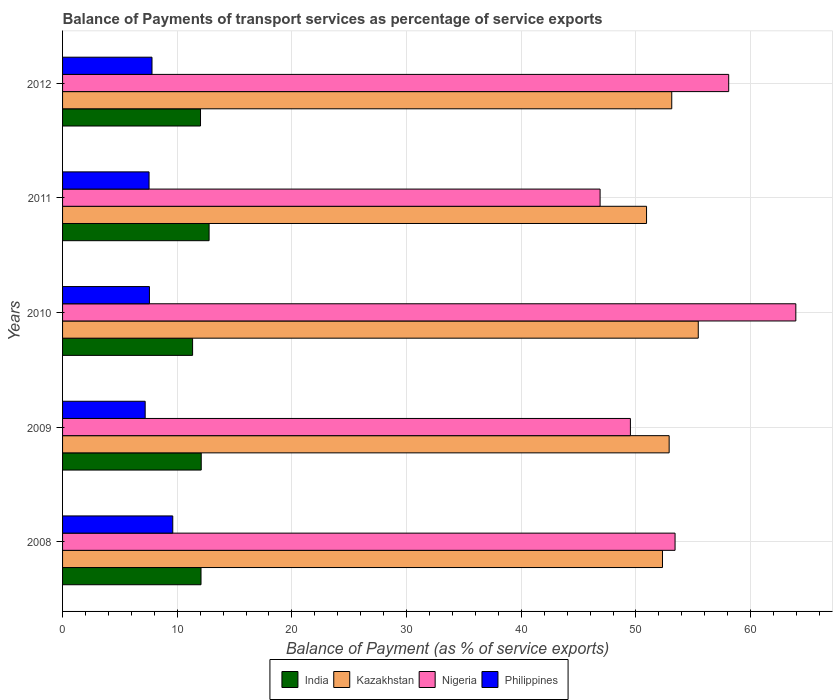How many different coloured bars are there?
Your answer should be very brief. 4. How many groups of bars are there?
Keep it short and to the point. 5. Are the number of bars per tick equal to the number of legend labels?
Give a very brief answer. Yes. Are the number of bars on each tick of the Y-axis equal?
Your answer should be very brief. Yes. How many bars are there on the 1st tick from the top?
Make the answer very short. 4. How many bars are there on the 1st tick from the bottom?
Provide a succinct answer. 4. What is the balance of payments of transport services in Philippines in 2011?
Provide a succinct answer. 7.54. Across all years, what is the maximum balance of payments of transport services in Philippines?
Give a very brief answer. 9.61. Across all years, what is the minimum balance of payments of transport services in Kazakhstan?
Offer a very short reply. 50.93. In which year was the balance of payments of transport services in Nigeria maximum?
Provide a succinct answer. 2010. In which year was the balance of payments of transport services in Nigeria minimum?
Give a very brief answer. 2011. What is the total balance of payments of transport services in Nigeria in the graph?
Offer a very short reply. 271.84. What is the difference between the balance of payments of transport services in Kazakhstan in 2009 and that in 2010?
Make the answer very short. -2.54. What is the difference between the balance of payments of transport services in Nigeria in 2009 and the balance of payments of transport services in Kazakhstan in 2011?
Your answer should be compact. -1.41. What is the average balance of payments of transport services in Philippines per year?
Offer a very short reply. 7.95. In the year 2009, what is the difference between the balance of payments of transport services in Nigeria and balance of payments of transport services in India?
Your answer should be compact. 37.43. What is the ratio of the balance of payments of transport services in Philippines in 2010 to that in 2011?
Ensure brevity in your answer.  1. Is the difference between the balance of payments of transport services in Nigeria in 2009 and 2010 greater than the difference between the balance of payments of transport services in India in 2009 and 2010?
Provide a succinct answer. No. What is the difference between the highest and the second highest balance of payments of transport services in India?
Offer a very short reply. 0.69. What is the difference between the highest and the lowest balance of payments of transport services in Nigeria?
Offer a terse response. 17.07. In how many years, is the balance of payments of transport services in Nigeria greater than the average balance of payments of transport services in Nigeria taken over all years?
Offer a terse response. 2. Is it the case that in every year, the sum of the balance of payments of transport services in Philippines and balance of payments of transport services in India is greater than the sum of balance of payments of transport services in Nigeria and balance of payments of transport services in Kazakhstan?
Offer a very short reply. No. What does the 4th bar from the top in 2011 represents?
Your answer should be compact. India. What does the 4th bar from the bottom in 2010 represents?
Provide a succinct answer. Philippines. How many years are there in the graph?
Your answer should be compact. 5. How are the legend labels stacked?
Your response must be concise. Horizontal. What is the title of the graph?
Your answer should be very brief. Balance of Payments of transport services as percentage of service exports. Does "Cameroon" appear as one of the legend labels in the graph?
Your answer should be very brief. No. What is the label or title of the X-axis?
Ensure brevity in your answer.  Balance of Payment (as % of service exports). What is the Balance of Payment (as % of service exports) in India in 2008?
Your answer should be compact. 12.07. What is the Balance of Payment (as % of service exports) in Kazakhstan in 2008?
Your answer should be very brief. 52.32. What is the Balance of Payment (as % of service exports) in Nigeria in 2008?
Make the answer very short. 53.41. What is the Balance of Payment (as % of service exports) in Philippines in 2008?
Your response must be concise. 9.61. What is the Balance of Payment (as % of service exports) in India in 2009?
Offer a very short reply. 12.09. What is the Balance of Payment (as % of service exports) of Kazakhstan in 2009?
Ensure brevity in your answer.  52.9. What is the Balance of Payment (as % of service exports) of Nigeria in 2009?
Give a very brief answer. 49.52. What is the Balance of Payment (as % of service exports) in Philippines in 2009?
Your answer should be compact. 7.2. What is the Balance of Payment (as % of service exports) of India in 2010?
Provide a succinct answer. 11.34. What is the Balance of Payment (as % of service exports) of Kazakhstan in 2010?
Give a very brief answer. 55.44. What is the Balance of Payment (as % of service exports) in Nigeria in 2010?
Give a very brief answer. 63.94. What is the Balance of Payment (as % of service exports) of Philippines in 2010?
Make the answer very short. 7.58. What is the Balance of Payment (as % of service exports) in India in 2011?
Your answer should be very brief. 12.78. What is the Balance of Payment (as % of service exports) of Kazakhstan in 2011?
Offer a terse response. 50.93. What is the Balance of Payment (as % of service exports) of Nigeria in 2011?
Your answer should be very brief. 46.87. What is the Balance of Payment (as % of service exports) in Philippines in 2011?
Offer a terse response. 7.54. What is the Balance of Payment (as % of service exports) in India in 2012?
Ensure brevity in your answer.  12.03. What is the Balance of Payment (as % of service exports) of Kazakhstan in 2012?
Your response must be concise. 53.12. What is the Balance of Payment (as % of service exports) in Nigeria in 2012?
Your answer should be very brief. 58.09. What is the Balance of Payment (as % of service exports) of Philippines in 2012?
Your answer should be very brief. 7.8. Across all years, what is the maximum Balance of Payment (as % of service exports) of India?
Your answer should be compact. 12.78. Across all years, what is the maximum Balance of Payment (as % of service exports) in Kazakhstan?
Provide a succinct answer. 55.44. Across all years, what is the maximum Balance of Payment (as % of service exports) of Nigeria?
Give a very brief answer. 63.94. Across all years, what is the maximum Balance of Payment (as % of service exports) of Philippines?
Make the answer very short. 9.61. Across all years, what is the minimum Balance of Payment (as % of service exports) in India?
Provide a succinct answer. 11.34. Across all years, what is the minimum Balance of Payment (as % of service exports) in Kazakhstan?
Your answer should be very brief. 50.93. Across all years, what is the minimum Balance of Payment (as % of service exports) of Nigeria?
Keep it short and to the point. 46.87. Across all years, what is the minimum Balance of Payment (as % of service exports) of Philippines?
Your response must be concise. 7.2. What is the total Balance of Payment (as % of service exports) in India in the graph?
Keep it short and to the point. 60.31. What is the total Balance of Payment (as % of service exports) in Kazakhstan in the graph?
Ensure brevity in your answer.  264.7. What is the total Balance of Payment (as % of service exports) of Nigeria in the graph?
Provide a short and direct response. 271.84. What is the total Balance of Payment (as % of service exports) of Philippines in the graph?
Your answer should be compact. 39.73. What is the difference between the Balance of Payment (as % of service exports) of India in 2008 and that in 2009?
Your answer should be very brief. -0.02. What is the difference between the Balance of Payment (as % of service exports) of Kazakhstan in 2008 and that in 2009?
Provide a short and direct response. -0.58. What is the difference between the Balance of Payment (as % of service exports) of Nigeria in 2008 and that in 2009?
Make the answer very short. 3.89. What is the difference between the Balance of Payment (as % of service exports) in Philippines in 2008 and that in 2009?
Ensure brevity in your answer.  2.41. What is the difference between the Balance of Payment (as % of service exports) of India in 2008 and that in 2010?
Make the answer very short. 0.73. What is the difference between the Balance of Payment (as % of service exports) of Kazakhstan in 2008 and that in 2010?
Make the answer very short. -3.12. What is the difference between the Balance of Payment (as % of service exports) in Nigeria in 2008 and that in 2010?
Provide a succinct answer. -10.53. What is the difference between the Balance of Payment (as % of service exports) of Philippines in 2008 and that in 2010?
Provide a short and direct response. 2.03. What is the difference between the Balance of Payment (as % of service exports) in India in 2008 and that in 2011?
Make the answer very short. -0.7. What is the difference between the Balance of Payment (as % of service exports) of Kazakhstan in 2008 and that in 2011?
Your answer should be compact. 1.39. What is the difference between the Balance of Payment (as % of service exports) in Nigeria in 2008 and that in 2011?
Offer a terse response. 6.54. What is the difference between the Balance of Payment (as % of service exports) in Philippines in 2008 and that in 2011?
Keep it short and to the point. 2.07. What is the difference between the Balance of Payment (as % of service exports) of India in 2008 and that in 2012?
Provide a succinct answer. 0.04. What is the difference between the Balance of Payment (as % of service exports) of Kazakhstan in 2008 and that in 2012?
Keep it short and to the point. -0.81. What is the difference between the Balance of Payment (as % of service exports) of Nigeria in 2008 and that in 2012?
Give a very brief answer. -4.68. What is the difference between the Balance of Payment (as % of service exports) in Philippines in 2008 and that in 2012?
Your answer should be compact. 1.81. What is the difference between the Balance of Payment (as % of service exports) of India in 2009 and that in 2010?
Provide a succinct answer. 0.75. What is the difference between the Balance of Payment (as % of service exports) of Kazakhstan in 2009 and that in 2010?
Provide a short and direct response. -2.54. What is the difference between the Balance of Payment (as % of service exports) of Nigeria in 2009 and that in 2010?
Offer a terse response. -14.43. What is the difference between the Balance of Payment (as % of service exports) of Philippines in 2009 and that in 2010?
Your answer should be very brief. -0.37. What is the difference between the Balance of Payment (as % of service exports) of India in 2009 and that in 2011?
Your answer should be very brief. -0.69. What is the difference between the Balance of Payment (as % of service exports) of Kazakhstan in 2009 and that in 2011?
Your response must be concise. 1.97. What is the difference between the Balance of Payment (as % of service exports) in Nigeria in 2009 and that in 2011?
Offer a very short reply. 2.64. What is the difference between the Balance of Payment (as % of service exports) of Philippines in 2009 and that in 2011?
Ensure brevity in your answer.  -0.34. What is the difference between the Balance of Payment (as % of service exports) in India in 2009 and that in 2012?
Provide a succinct answer. 0.06. What is the difference between the Balance of Payment (as % of service exports) of Kazakhstan in 2009 and that in 2012?
Give a very brief answer. -0.23. What is the difference between the Balance of Payment (as % of service exports) of Nigeria in 2009 and that in 2012?
Keep it short and to the point. -8.57. What is the difference between the Balance of Payment (as % of service exports) of Philippines in 2009 and that in 2012?
Give a very brief answer. -0.59. What is the difference between the Balance of Payment (as % of service exports) of India in 2010 and that in 2011?
Your answer should be very brief. -1.44. What is the difference between the Balance of Payment (as % of service exports) in Kazakhstan in 2010 and that in 2011?
Keep it short and to the point. 4.51. What is the difference between the Balance of Payment (as % of service exports) in Nigeria in 2010 and that in 2011?
Provide a succinct answer. 17.07. What is the difference between the Balance of Payment (as % of service exports) in Philippines in 2010 and that in 2011?
Your answer should be compact. 0.03. What is the difference between the Balance of Payment (as % of service exports) in India in 2010 and that in 2012?
Make the answer very short. -0.69. What is the difference between the Balance of Payment (as % of service exports) in Kazakhstan in 2010 and that in 2012?
Give a very brief answer. 2.31. What is the difference between the Balance of Payment (as % of service exports) in Nigeria in 2010 and that in 2012?
Your answer should be very brief. 5.85. What is the difference between the Balance of Payment (as % of service exports) in Philippines in 2010 and that in 2012?
Offer a very short reply. -0.22. What is the difference between the Balance of Payment (as % of service exports) in India in 2011 and that in 2012?
Your answer should be compact. 0.75. What is the difference between the Balance of Payment (as % of service exports) in Kazakhstan in 2011 and that in 2012?
Offer a very short reply. -2.2. What is the difference between the Balance of Payment (as % of service exports) in Nigeria in 2011 and that in 2012?
Make the answer very short. -11.22. What is the difference between the Balance of Payment (as % of service exports) of Philippines in 2011 and that in 2012?
Provide a succinct answer. -0.26. What is the difference between the Balance of Payment (as % of service exports) in India in 2008 and the Balance of Payment (as % of service exports) in Kazakhstan in 2009?
Provide a succinct answer. -40.82. What is the difference between the Balance of Payment (as % of service exports) in India in 2008 and the Balance of Payment (as % of service exports) in Nigeria in 2009?
Your response must be concise. -37.45. What is the difference between the Balance of Payment (as % of service exports) in India in 2008 and the Balance of Payment (as % of service exports) in Philippines in 2009?
Offer a very short reply. 4.87. What is the difference between the Balance of Payment (as % of service exports) in Kazakhstan in 2008 and the Balance of Payment (as % of service exports) in Nigeria in 2009?
Your response must be concise. 2.8. What is the difference between the Balance of Payment (as % of service exports) of Kazakhstan in 2008 and the Balance of Payment (as % of service exports) of Philippines in 2009?
Provide a short and direct response. 45.11. What is the difference between the Balance of Payment (as % of service exports) in Nigeria in 2008 and the Balance of Payment (as % of service exports) in Philippines in 2009?
Provide a succinct answer. 46.21. What is the difference between the Balance of Payment (as % of service exports) of India in 2008 and the Balance of Payment (as % of service exports) of Kazakhstan in 2010?
Your answer should be compact. -43.36. What is the difference between the Balance of Payment (as % of service exports) in India in 2008 and the Balance of Payment (as % of service exports) in Nigeria in 2010?
Provide a succinct answer. -51.87. What is the difference between the Balance of Payment (as % of service exports) of India in 2008 and the Balance of Payment (as % of service exports) of Philippines in 2010?
Provide a succinct answer. 4.5. What is the difference between the Balance of Payment (as % of service exports) of Kazakhstan in 2008 and the Balance of Payment (as % of service exports) of Nigeria in 2010?
Provide a short and direct response. -11.63. What is the difference between the Balance of Payment (as % of service exports) of Kazakhstan in 2008 and the Balance of Payment (as % of service exports) of Philippines in 2010?
Your response must be concise. 44.74. What is the difference between the Balance of Payment (as % of service exports) of Nigeria in 2008 and the Balance of Payment (as % of service exports) of Philippines in 2010?
Offer a terse response. 45.84. What is the difference between the Balance of Payment (as % of service exports) in India in 2008 and the Balance of Payment (as % of service exports) in Kazakhstan in 2011?
Your answer should be very brief. -38.85. What is the difference between the Balance of Payment (as % of service exports) in India in 2008 and the Balance of Payment (as % of service exports) in Nigeria in 2011?
Your answer should be compact. -34.8. What is the difference between the Balance of Payment (as % of service exports) of India in 2008 and the Balance of Payment (as % of service exports) of Philippines in 2011?
Give a very brief answer. 4.53. What is the difference between the Balance of Payment (as % of service exports) of Kazakhstan in 2008 and the Balance of Payment (as % of service exports) of Nigeria in 2011?
Keep it short and to the point. 5.44. What is the difference between the Balance of Payment (as % of service exports) of Kazakhstan in 2008 and the Balance of Payment (as % of service exports) of Philippines in 2011?
Your answer should be compact. 44.77. What is the difference between the Balance of Payment (as % of service exports) in Nigeria in 2008 and the Balance of Payment (as % of service exports) in Philippines in 2011?
Your answer should be compact. 45.87. What is the difference between the Balance of Payment (as % of service exports) of India in 2008 and the Balance of Payment (as % of service exports) of Kazakhstan in 2012?
Ensure brevity in your answer.  -41.05. What is the difference between the Balance of Payment (as % of service exports) in India in 2008 and the Balance of Payment (as % of service exports) in Nigeria in 2012?
Your answer should be compact. -46.02. What is the difference between the Balance of Payment (as % of service exports) of India in 2008 and the Balance of Payment (as % of service exports) of Philippines in 2012?
Keep it short and to the point. 4.27. What is the difference between the Balance of Payment (as % of service exports) in Kazakhstan in 2008 and the Balance of Payment (as % of service exports) in Nigeria in 2012?
Your response must be concise. -5.78. What is the difference between the Balance of Payment (as % of service exports) of Kazakhstan in 2008 and the Balance of Payment (as % of service exports) of Philippines in 2012?
Make the answer very short. 44.52. What is the difference between the Balance of Payment (as % of service exports) in Nigeria in 2008 and the Balance of Payment (as % of service exports) in Philippines in 2012?
Your answer should be compact. 45.61. What is the difference between the Balance of Payment (as % of service exports) in India in 2009 and the Balance of Payment (as % of service exports) in Kazakhstan in 2010?
Ensure brevity in your answer.  -43.34. What is the difference between the Balance of Payment (as % of service exports) of India in 2009 and the Balance of Payment (as % of service exports) of Nigeria in 2010?
Ensure brevity in your answer.  -51.85. What is the difference between the Balance of Payment (as % of service exports) of India in 2009 and the Balance of Payment (as % of service exports) of Philippines in 2010?
Provide a succinct answer. 4.52. What is the difference between the Balance of Payment (as % of service exports) in Kazakhstan in 2009 and the Balance of Payment (as % of service exports) in Nigeria in 2010?
Keep it short and to the point. -11.05. What is the difference between the Balance of Payment (as % of service exports) of Kazakhstan in 2009 and the Balance of Payment (as % of service exports) of Philippines in 2010?
Your answer should be very brief. 45.32. What is the difference between the Balance of Payment (as % of service exports) of Nigeria in 2009 and the Balance of Payment (as % of service exports) of Philippines in 2010?
Your answer should be very brief. 41.94. What is the difference between the Balance of Payment (as % of service exports) of India in 2009 and the Balance of Payment (as % of service exports) of Kazakhstan in 2011?
Provide a succinct answer. -38.83. What is the difference between the Balance of Payment (as % of service exports) in India in 2009 and the Balance of Payment (as % of service exports) in Nigeria in 2011?
Give a very brief answer. -34.78. What is the difference between the Balance of Payment (as % of service exports) in India in 2009 and the Balance of Payment (as % of service exports) in Philippines in 2011?
Your response must be concise. 4.55. What is the difference between the Balance of Payment (as % of service exports) of Kazakhstan in 2009 and the Balance of Payment (as % of service exports) of Nigeria in 2011?
Provide a short and direct response. 6.02. What is the difference between the Balance of Payment (as % of service exports) of Kazakhstan in 2009 and the Balance of Payment (as % of service exports) of Philippines in 2011?
Your answer should be very brief. 45.36. What is the difference between the Balance of Payment (as % of service exports) in Nigeria in 2009 and the Balance of Payment (as % of service exports) in Philippines in 2011?
Your answer should be very brief. 41.98. What is the difference between the Balance of Payment (as % of service exports) in India in 2009 and the Balance of Payment (as % of service exports) in Kazakhstan in 2012?
Your response must be concise. -41.03. What is the difference between the Balance of Payment (as % of service exports) of India in 2009 and the Balance of Payment (as % of service exports) of Nigeria in 2012?
Provide a succinct answer. -46. What is the difference between the Balance of Payment (as % of service exports) of India in 2009 and the Balance of Payment (as % of service exports) of Philippines in 2012?
Give a very brief answer. 4.29. What is the difference between the Balance of Payment (as % of service exports) in Kazakhstan in 2009 and the Balance of Payment (as % of service exports) in Nigeria in 2012?
Give a very brief answer. -5.19. What is the difference between the Balance of Payment (as % of service exports) in Kazakhstan in 2009 and the Balance of Payment (as % of service exports) in Philippines in 2012?
Keep it short and to the point. 45.1. What is the difference between the Balance of Payment (as % of service exports) in Nigeria in 2009 and the Balance of Payment (as % of service exports) in Philippines in 2012?
Provide a short and direct response. 41.72. What is the difference between the Balance of Payment (as % of service exports) of India in 2010 and the Balance of Payment (as % of service exports) of Kazakhstan in 2011?
Give a very brief answer. -39.59. What is the difference between the Balance of Payment (as % of service exports) in India in 2010 and the Balance of Payment (as % of service exports) in Nigeria in 2011?
Your answer should be very brief. -35.53. What is the difference between the Balance of Payment (as % of service exports) in India in 2010 and the Balance of Payment (as % of service exports) in Philippines in 2011?
Offer a terse response. 3.8. What is the difference between the Balance of Payment (as % of service exports) of Kazakhstan in 2010 and the Balance of Payment (as % of service exports) of Nigeria in 2011?
Offer a very short reply. 8.56. What is the difference between the Balance of Payment (as % of service exports) of Kazakhstan in 2010 and the Balance of Payment (as % of service exports) of Philippines in 2011?
Your answer should be compact. 47.89. What is the difference between the Balance of Payment (as % of service exports) of Nigeria in 2010 and the Balance of Payment (as % of service exports) of Philippines in 2011?
Ensure brevity in your answer.  56.4. What is the difference between the Balance of Payment (as % of service exports) in India in 2010 and the Balance of Payment (as % of service exports) in Kazakhstan in 2012?
Your answer should be very brief. -41.78. What is the difference between the Balance of Payment (as % of service exports) of India in 2010 and the Balance of Payment (as % of service exports) of Nigeria in 2012?
Your answer should be very brief. -46.75. What is the difference between the Balance of Payment (as % of service exports) of India in 2010 and the Balance of Payment (as % of service exports) of Philippines in 2012?
Ensure brevity in your answer.  3.54. What is the difference between the Balance of Payment (as % of service exports) of Kazakhstan in 2010 and the Balance of Payment (as % of service exports) of Nigeria in 2012?
Your answer should be compact. -2.65. What is the difference between the Balance of Payment (as % of service exports) of Kazakhstan in 2010 and the Balance of Payment (as % of service exports) of Philippines in 2012?
Keep it short and to the point. 47.64. What is the difference between the Balance of Payment (as % of service exports) of Nigeria in 2010 and the Balance of Payment (as % of service exports) of Philippines in 2012?
Offer a very short reply. 56.15. What is the difference between the Balance of Payment (as % of service exports) of India in 2011 and the Balance of Payment (as % of service exports) of Kazakhstan in 2012?
Make the answer very short. -40.35. What is the difference between the Balance of Payment (as % of service exports) in India in 2011 and the Balance of Payment (as % of service exports) in Nigeria in 2012?
Offer a terse response. -45.31. What is the difference between the Balance of Payment (as % of service exports) in India in 2011 and the Balance of Payment (as % of service exports) in Philippines in 2012?
Provide a succinct answer. 4.98. What is the difference between the Balance of Payment (as % of service exports) in Kazakhstan in 2011 and the Balance of Payment (as % of service exports) in Nigeria in 2012?
Provide a short and direct response. -7.16. What is the difference between the Balance of Payment (as % of service exports) of Kazakhstan in 2011 and the Balance of Payment (as % of service exports) of Philippines in 2012?
Give a very brief answer. 43.13. What is the difference between the Balance of Payment (as % of service exports) of Nigeria in 2011 and the Balance of Payment (as % of service exports) of Philippines in 2012?
Keep it short and to the point. 39.08. What is the average Balance of Payment (as % of service exports) in India per year?
Ensure brevity in your answer.  12.06. What is the average Balance of Payment (as % of service exports) in Kazakhstan per year?
Give a very brief answer. 52.94. What is the average Balance of Payment (as % of service exports) of Nigeria per year?
Offer a very short reply. 54.37. What is the average Balance of Payment (as % of service exports) in Philippines per year?
Keep it short and to the point. 7.95. In the year 2008, what is the difference between the Balance of Payment (as % of service exports) of India and Balance of Payment (as % of service exports) of Kazakhstan?
Your answer should be very brief. -40.24. In the year 2008, what is the difference between the Balance of Payment (as % of service exports) of India and Balance of Payment (as % of service exports) of Nigeria?
Provide a short and direct response. -41.34. In the year 2008, what is the difference between the Balance of Payment (as % of service exports) in India and Balance of Payment (as % of service exports) in Philippines?
Ensure brevity in your answer.  2.46. In the year 2008, what is the difference between the Balance of Payment (as % of service exports) of Kazakhstan and Balance of Payment (as % of service exports) of Nigeria?
Offer a terse response. -1.1. In the year 2008, what is the difference between the Balance of Payment (as % of service exports) of Kazakhstan and Balance of Payment (as % of service exports) of Philippines?
Give a very brief answer. 42.71. In the year 2008, what is the difference between the Balance of Payment (as % of service exports) in Nigeria and Balance of Payment (as % of service exports) in Philippines?
Give a very brief answer. 43.8. In the year 2009, what is the difference between the Balance of Payment (as % of service exports) of India and Balance of Payment (as % of service exports) of Kazakhstan?
Offer a very short reply. -40.81. In the year 2009, what is the difference between the Balance of Payment (as % of service exports) of India and Balance of Payment (as % of service exports) of Nigeria?
Your response must be concise. -37.43. In the year 2009, what is the difference between the Balance of Payment (as % of service exports) of India and Balance of Payment (as % of service exports) of Philippines?
Ensure brevity in your answer.  4.89. In the year 2009, what is the difference between the Balance of Payment (as % of service exports) of Kazakhstan and Balance of Payment (as % of service exports) of Nigeria?
Your answer should be very brief. 3.38. In the year 2009, what is the difference between the Balance of Payment (as % of service exports) of Kazakhstan and Balance of Payment (as % of service exports) of Philippines?
Offer a terse response. 45.69. In the year 2009, what is the difference between the Balance of Payment (as % of service exports) in Nigeria and Balance of Payment (as % of service exports) in Philippines?
Provide a short and direct response. 42.31. In the year 2010, what is the difference between the Balance of Payment (as % of service exports) in India and Balance of Payment (as % of service exports) in Kazakhstan?
Your response must be concise. -44.1. In the year 2010, what is the difference between the Balance of Payment (as % of service exports) in India and Balance of Payment (as % of service exports) in Nigeria?
Offer a terse response. -52.6. In the year 2010, what is the difference between the Balance of Payment (as % of service exports) of India and Balance of Payment (as % of service exports) of Philippines?
Offer a very short reply. 3.76. In the year 2010, what is the difference between the Balance of Payment (as % of service exports) of Kazakhstan and Balance of Payment (as % of service exports) of Nigeria?
Make the answer very short. -8.51. In the year 2010, what is the difference between the Balance of Payment (as % of service exports) of Kazakhstan and Balance of Payment (as % of service exports) of Philippines?
Your response must be concise. 47.86. In the year 2010, what is the difference between the Balance of Payment (as % of service exports) of Nigeria and Balance of Payment (as % of service exports) of Philippines?
Offer a terse response. 56.37. In the year 2011, what is the difference between the Balance of Payment (as % of service exports) of India and Balance of Payment (as % of service exports) of Kazakhstan?
Your response must be concise. -38.15. In the year 2011, what is the difference between the Balance of Payment (as % of service exports) of India and Balance of Payment (as % of service exports) of Nigeria?
Make the answer very short. -34.1. In the year 2011, what is the difference between the Balance of Payment (as % of service exports) in India and Balance of Payment (as % of service exports) in Philippines?
Offer a terse response. 5.24. In the year 2011, what is the difference between the Balance of Payment (as % of service exports) in Kazakhstan and Balance of Payment (as % of service exports) in Nigeria?
Ensure brevity in your answer.  4.05. In the year 2011, what is the difference between the Balance of Payment (as % of service exports) of Kazakhstan and Balance of Payment (as % of service exports) of Philippines?
Provide a succinct answer. 43.38. In the year 2011, what is the difference between the Balance of Payment (as % of service exports) of Nigeria and Balance of Payment (as % of service exports) of Philippines?
Your answer should be very brief. 39.33. In the year 2012, what is the difference between the Balance of Payment (as % of service exports) in India and Balance of Payment (as % of service exports) in Kazakhstan?
Make the answer very short. -41.09. In the year 2012, what is the difference between the Balance of Payment (as % of service exports) in India and Balance of Payment (as % of service exports) in Nigeria?
Ensure brevity in your answer.  -46.06. In the year 2012, what is the difference between the Balance of Payment (as % of service exports) in India and Balance of Payment (as % of service exports) in Philippines?
Make the answer very short. 4.23. In the year 2012, what is the difference between the Balance of Payment (as % of service exports) of Kazakhstan and Balance of Payment (as % of service exports) of Nigeria?
Make the answer very short. -4.97. In the year 2012, what is the difference between the Balance of Payment (as % of service exports) of Kazakhstan and Balance of Payment (as % of service exports) of Philippines?
Give a very brief answer. 45.33. In the year 2012, what is the difference between the Balance of Payment (as % of service exports) of Nigeria and Balance of Payment (as % of service exports) of Philippines?
Provide a succinct answer. 50.29. What is the ratio of the Balance of Payment (as % of service exports) of India in 2008 to that in 2009?
Provide a short and direct response. 1. What is the ratio of the Balance of Payment (as % of service exports) in Kazakhstan in 2008 to that in 2009?
Provide a short and direct response. 0.99. What is the ratio of the Balance of Payment (as % of service exports) of Nigeria in 2008 to that in 2009?
Keep it short and to the point. 1.08. What is the ratio of the Balance of Payment (as % of service exports) of Philippines in 2008 to that in 2009?
Ensure brevity in your answer.  1.33. What is the ratio of the Balance of Payment (as % of service exports) of India in 2008 to that in 2010?
Offer a very short reply. 1.06. What is the ratio of the Balance of Payment (as % of service exports) in Kazakhstan in 2008 to that in 2010?
Your response must be concise. 0.94. What is the ratio of the Balance of Payment (as % of service exports) of Nigeria in 2008 to that in 2010?
Ensure brevity in your answer.  0.84. What is the ratio of the Balance of Payment (as % of service exports) of Philippines in 2008 to that in 2010?
Your answer should be very brief. 1.27. What is the ratio of the Balance of Payment (as % of service exports) in India in 2008 to that in 2011?
Provide a succinct answer. 0.94. What is the ratio of the Balance of Payment (as % of service exports) of Kazakhstan in 2008 to that in 2011?
Keep it short and to the point. 1.03. What is the ratio of the Balance of Payment (as % of service exports) of Nigeria in 2008 to that in 2011?
Provide a succinct answer. 1.14. What is the ratio of the Balance of Payment (as % of service exports) in Philippines in 2008 to that in 2011?
Offer a very short reply. 1.27. What is the ratio of the Balance of Payment (as % of service exports) in India in 2008 to that in 2012?
Provide a succinct answer. 1. What is the ratio of the Balance of Payment (as % of service exports) in Kazakhstan in 2008 to that in 2012?
Provide a succinct answer. 0.98. What is the ratio of the Balance of Payment (as % of service exports) of Nigeria in 2008 to that in 2012?
Provide a succinct answer. 0.92. What is the ratio of the Balance of Payment (as % of service exports) of Philippines in 2008 to that in 2012?
Ensure brevity in your answer.  1.23. What is the ratio of the Balance of Payment (as % of service exports) in India in 2009 to that in 2010?
Provide a succinct answer. 1.07. What is the ratio of the Balance of Payment (as % of service exports) of Kazakhstan in 2009 to that in 2010?
Your answer should be compact. 0.95. What is the ratio of the Balance of Payment (as % of service exports) of Nigeria in 2009 to that in 2010?
Ensure brevity in your answer.  0.77. What is the ratio of the Balance of Payment (as % of service exports) in Philippines in 2009 to that in 2010?
Provide a short and direct response. 0.95. What is the ratio of the Balance of Payment (as % of service exports) of India in 2009 to that in 2011?
Your response must be concise. 0.95. What is the ratio of the Balance of Payment (as % of service exports) in Kazakhstan in 2009 to that in 2011?
Offer a very short reply. 1.04. What is the ratio of the Balance of Payment (as % of service exports) of Nigeria in 2009 to that in 2011?
Your answer should be very brief. 1.06. What is the ratio of the Balance of Payment (as % of service exports) in Philippines in 2009 to that in 2011?
Provide a short and direct response. 0.96. What is the ratio of the Balance of Payment (as % of service exports) of India in 2009 to that in 2012?
Offer a very short reply. 1.01. What is the ratio of the Balance of Payment (as % of service exports) of Kazakhstan in 2009 to that in 2012?
Make the answer very short. 1. What is the ratio of the Balance of Payment (as % of service exports) of Nigeria in 2009 to that in 2012?
Give a very brief answer. 0.85. What is the ratio of the Balance of Payment (as % of service exports) in Philippines in 2009 to that in 2012?
Provide a succinct answer. 0.92. What is the ratio of the Balance of Payment (as % of service exports) in India in 2010 to that in 2011?
Offer a very short reply. 0.89. What is the ratio of the Balance of Payment (as % of service exports) of Kazakhstan in 2010 to that in 2011?
Provide a short and direct response. 1.09. What is the ratio of the Balance of Payment (as % of service exports) of Nigeria in 2010 to that in 2011?
Provide a succinct answer. 1.36. What is the ratio of the Balance of Payment (as % of service exports) of India in 2010 to that in 2012?
Give a very brief answer. 0.94. What is the ratio of the Balance of Payment (as % of service exports) in Kazakhstan in 2010 to that in 2012?
Offer a terse response. 1.04. What is the ratio of the Balance of Payment (as % of service exports) in Nigeria in 2010 to that in 2012?
Provide a succinct answer. 1.1. What is the ratio of the Balance of Payment (as % of service exports) in Philippines in 2010 to that in 2012?
Offer a terse response. 0.97. What is the ratio of the Balance of Payment (as % of service exports) of India in 2011 to that in 2012?
Your answer should be very brief. 1.06. What is the ratio of the Balance of Payment (as % of service exports) of Kazakhstan in 2011 to that in 2012?
Offer a terse response. 0.96. What is the ratio of the Balance of Payment (as % of service exports) of Nigeria in 2011 to that in 2012?
Offer a very short reply. 0.81. What is the ratio of the Balance of Payment (as % of service exports) of Philippines in 2011 to that in 2012?
Offer a terse response. 0.97. What is the difference between the highest and the second highest Balance of Payment (as % of service exports) of India?
Make the answer very short. 0.69. What is the difference between the highest and the second highest Balance of Payment (as % of service exports) in Kazakhstan?
Provide a short and direct response. 2.31. What is the difference between the highest and the second highest Balance of Payment (as % of service exports) in Nigeria?
Your response must be concise. 5.85. What is the difference between the highest and the second highest Balance of Payment (as % of service exports) in Philippines?
Make the answer very short. 1.81. What is the difference between the highest and the lowest Balance of Payment (as % of service exports) in India?
Your answer should be compact. 1.44. What is the difference between the highest and the lowest Balance of Payment (as % of service exports) of Kazakhstan?
Provide a succinct answer. 4.51. What is the difference between the highest and the lowest Balance of Payment (as % of service exports) of Nigeria?
Give a very brief answer. 17.07. What is the difference between the highest and the lowest Balance of Payment (as % of service exports) of Philippines?
Provide a succinct answer. 2.41. 